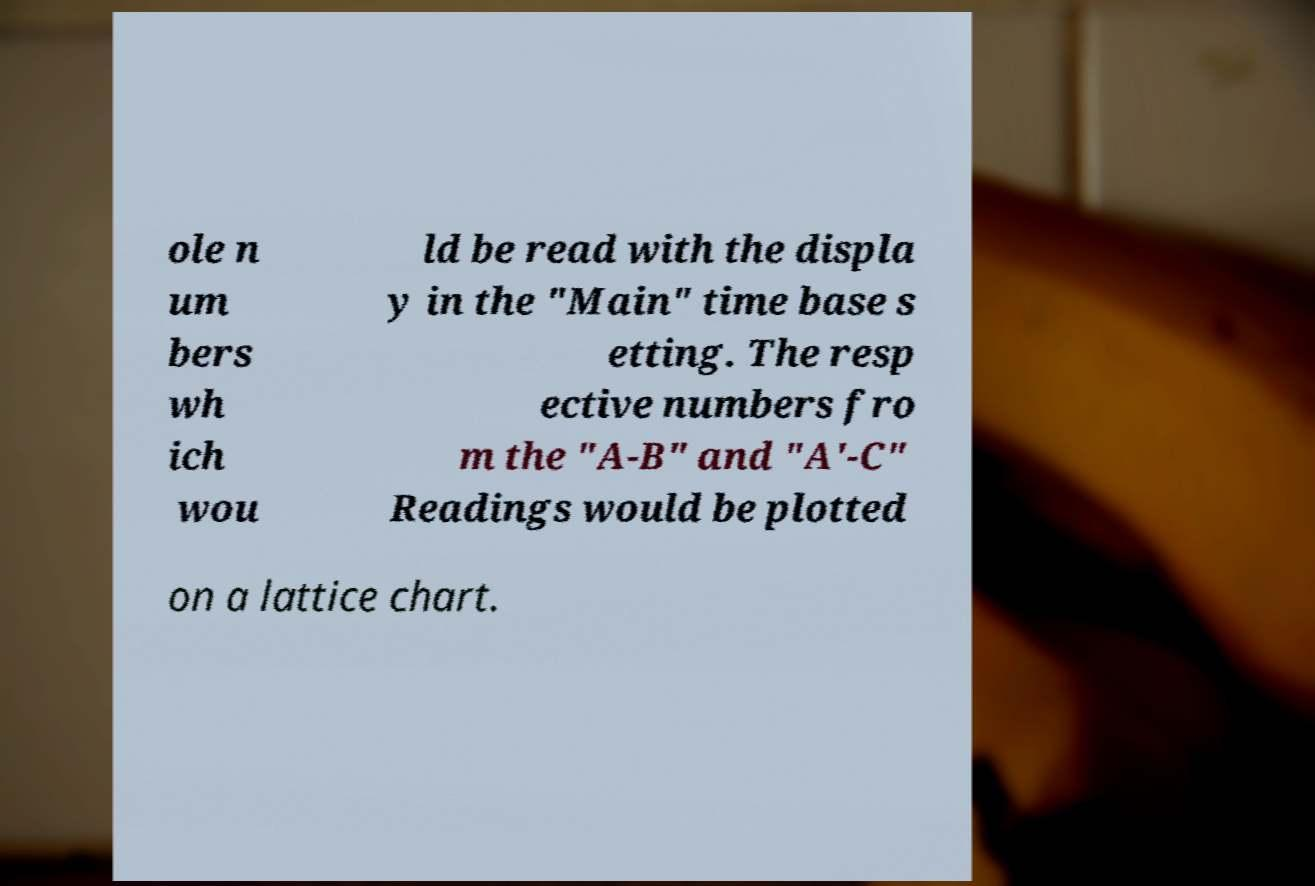Can you accurately transcribe the text from the provided image for me? ole n um bers wh ich wou ld be read with the displa y in the "Main" time base s etting. The resp ective numbers fro m the "A-B" and "A′-C" Readings would be plotted on a lattice chart. 